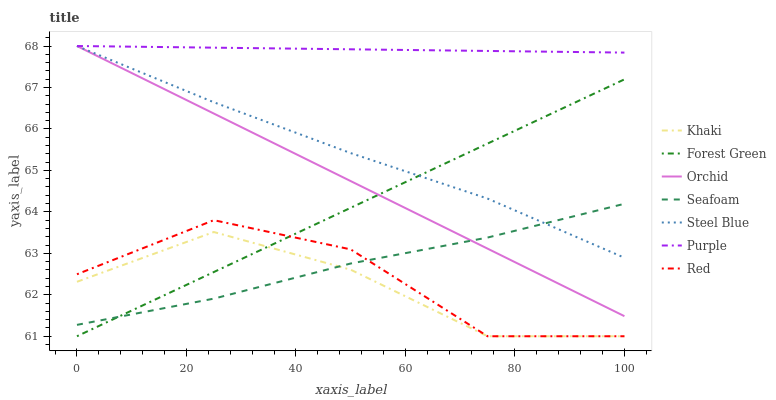Does Khaki have the minimum area under the curve?
Answer yes or no. Yes. Does Purple have the maximum area under the curve?
Answer yes or no. Yes. Does Seafoam have the minimum area under the curve?
Answer yes or no. No. Does Seafoam have the maximum area under the curve?
Answer yes or no. No. Is Purple the smoothest?
Answer yes or no. Yes. Is Red the roughest?
Answer yes or no. Yes. Is Seafoam the smoothest?
Answer yes or no. No. Is Seafoam the roughest?
Answer yes or no. No. Does Khaki have the lowest value?
Answer yes or no. Yes. Does Seafoam have the lowest value?
Answer yes or no. No. Does Orchid have the highest value?
Answer yes or no. Yes. Does Seafoam have the highest value?
Answer yes or no. No. Is Khaki less than Steel Blue?
Answer yes or no. Yes. Is Purple greater than Khaki?
Answer yes or no. Yes. Does Steel Blue intersect Orchid?
Answer yes or no. Yes. Is Steel Blue less than Orchid?
Answer yes or no. No. Is Steel Blue greater than Orchid?
Answer yes or no. No. Does Khaki intersect Steel Blue?
Answer yes or no. No. 